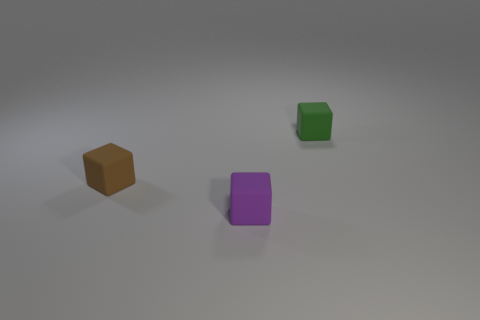How many other objects are there of the same shape as the green thing?
Keep it short and to the point. 2. There is a cube in front of the small brown matte object; what color is it?
Ensure brevity in your answer.  Purple. Do the brown object and the green rubber block have the same size?
Your answer should be compact. Yes. There is a object that is left of the cube that is in front of the small brown thing; what is it made of?
Give a very brief answer. Rubber. Are there any other things that are the same material as the green block?
Offer a very short reply. Yes. Are there fewer small green rubber cubes that are to the left of the tiny purple matte cube than tiny green cubes?
Make the answer very short. Yes. What is the color of the small matte object to the left of the thing that is in front of the brown rubber block?
Offer a very short reply. Brown. How big is the rubber object that is in front of the small matte object on the left side of the matte block in front of the tiny brown cube?
Offer a terse response. Small. Are there fewer small things that are on the left side of the brown object than blocks on the right side of the tiny purple thing?
Ensure brevity in your answer.  Yes. How many purple cubes are made of the same material as the brown cube?
Offer a very short reply. 1. 